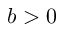Convert formula to latex. <formula><loc_0><loc_0><loc_500><loc_500>b > 0</formula> 